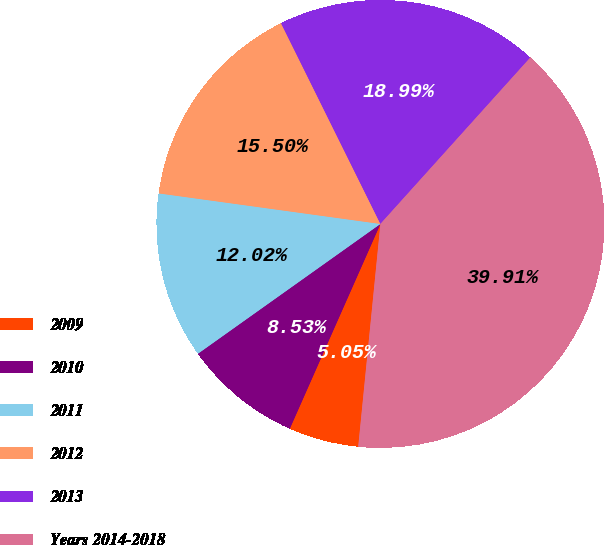Convert chart. <chart><loc_0><loc_0><loc_500><loc_500><pie_chart><fcel>2009<fcel>2010<fcel>2011<fcel>2012<fcel>2013<fcel>Years 2014-2018<nl><fcel>5.05%<fcel>8.53%<fcel>12.02%<fcel>15.5%<fcel>18.99%<fcel>39.91%<nl></chart> 